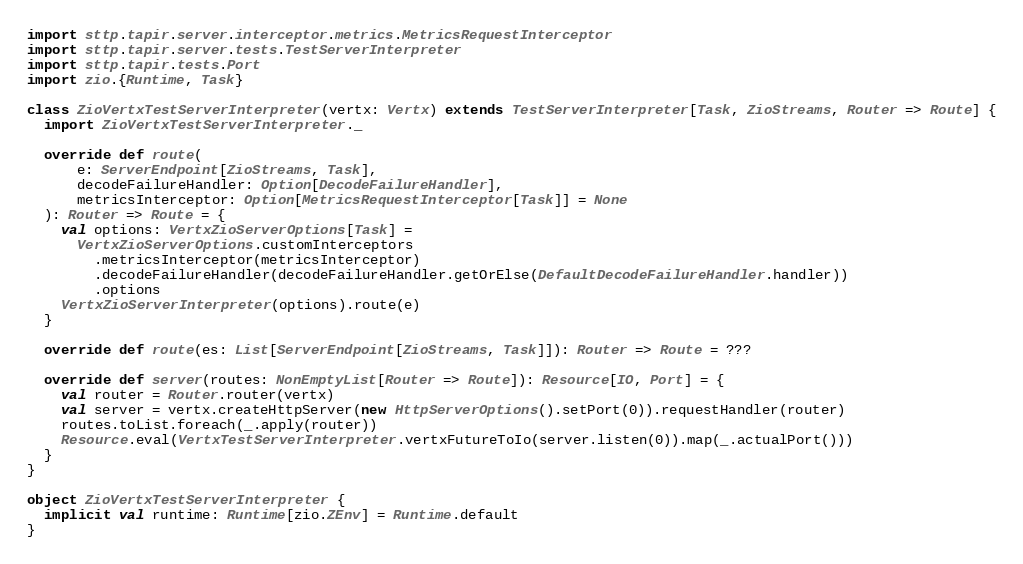Convert code to text. <code><loc_0><loc_0><loc_500><loc_500><_Scala_>import sttp.tapir.server.interceptor.metrics.MetricsRequestInterceptor
import sttp.tapir.server.tests.TestServerInterpreter
import sttp.tapir.tests.Port
import zio.{Runtime, Task}

class ZioVertxTestServerInterpreter(vertx: Vertx) extends TestServerInterpreter[Task, ZioStreams, Router => Route] {
  import ZioVertxTestServerInterpreter._

  override def route(
      e: ServerEndpoint[ZioStreams, Task],
      decodeFailureHandler: Option[DecodeFailureHandler],
      metricsInterceptor: Option[MetricsRequestInterceptor[Task]] = None
  ): Router => Route = {
    val options: VertxZioServerOptions[Task] =
      VertxZioServerOptions.customInterceptors
        .metricsInterceptor(metricsInterceptor)
        .decodeFailureHandler(decodeFailureHandler.getOrElse(DefaultDecodeFailureHandler.handler))
        .options
    VertxZioServerInterpreter(options).route(e)
  }

  override def route(es: List[ServerEndpoint[ZioStreams, Task]]): Router => Route = ???

  override def server(routes: NonEmptyList[Router => Route]): Resource[IO, Port] = {
    val router = Router.router(vertx)
    val server = vertx.createHttpServer(new HttpServerOptions().setPort(0)).requestHandler(router)
    routes.toList.foreach(_.apply(router))
    Resource.eval(VertxTestServerInterpreter.vertxFutureToIo(server.listen(0)).map(_.actualPort()))
  }
}

object ZioVertxTestServerInterpreter {
  implicit val runtime: Runtime[zio.ZEnv] = Runtime.default
}
</code> 